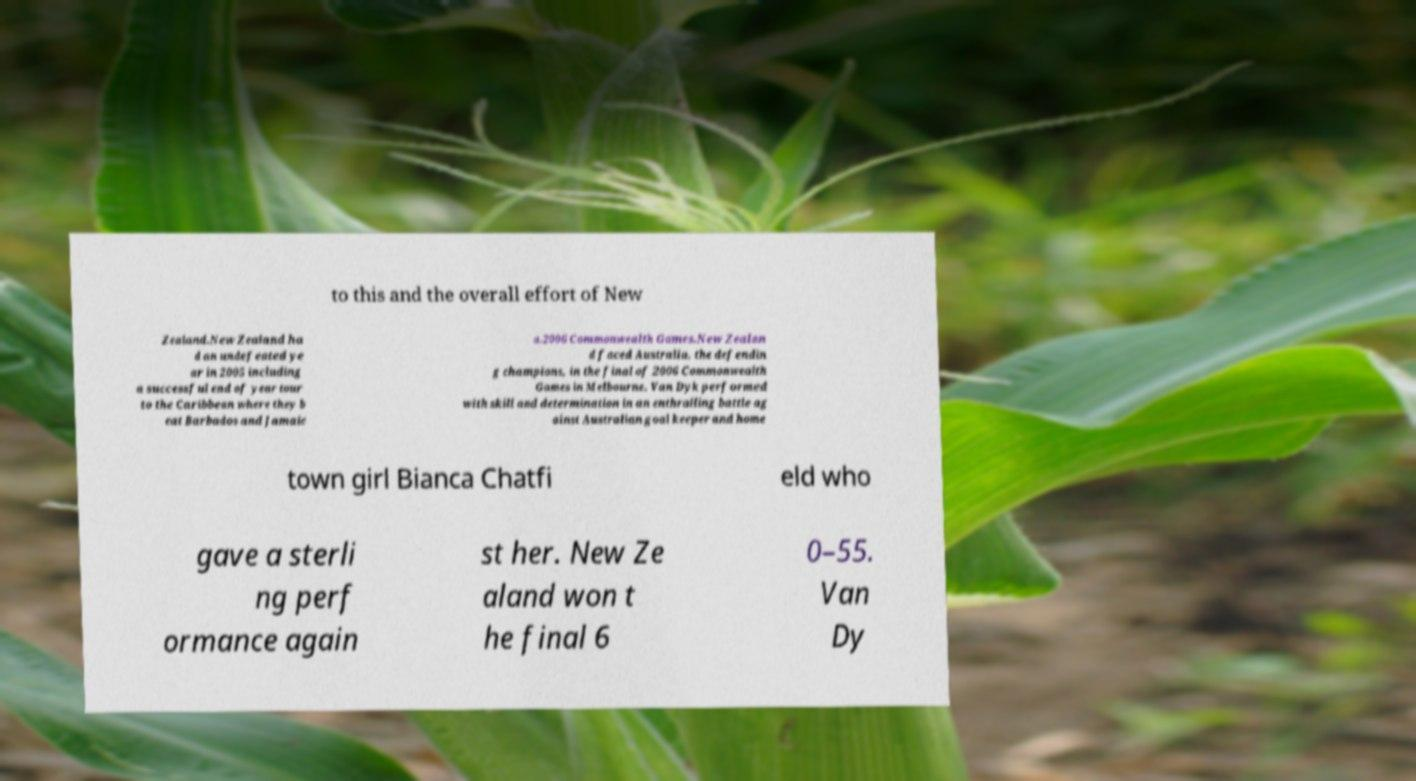What messages or text are displayed in this image? I need them in a readable, typed format. to this and the overall effort of New Zealand.New Zealand ha d an undefeated ye ar in 2005 including a successful end of year tour to the Caribbean where they b eat Barbados and Jamaic a.2006 Commonwealth Games.New Zealan d faced Australia, the defendin g champions, in the final of 2006 Commonwealth Games in Melbourne. Van Dyk performed with skill and determination in an enthralling battle ag ainst Australian goal keeper and home town girl Bianca Chatfi eld who gave a sterli ng perf ormance again st her. New Ze aland won t he final 6 0–55. Van Dy 